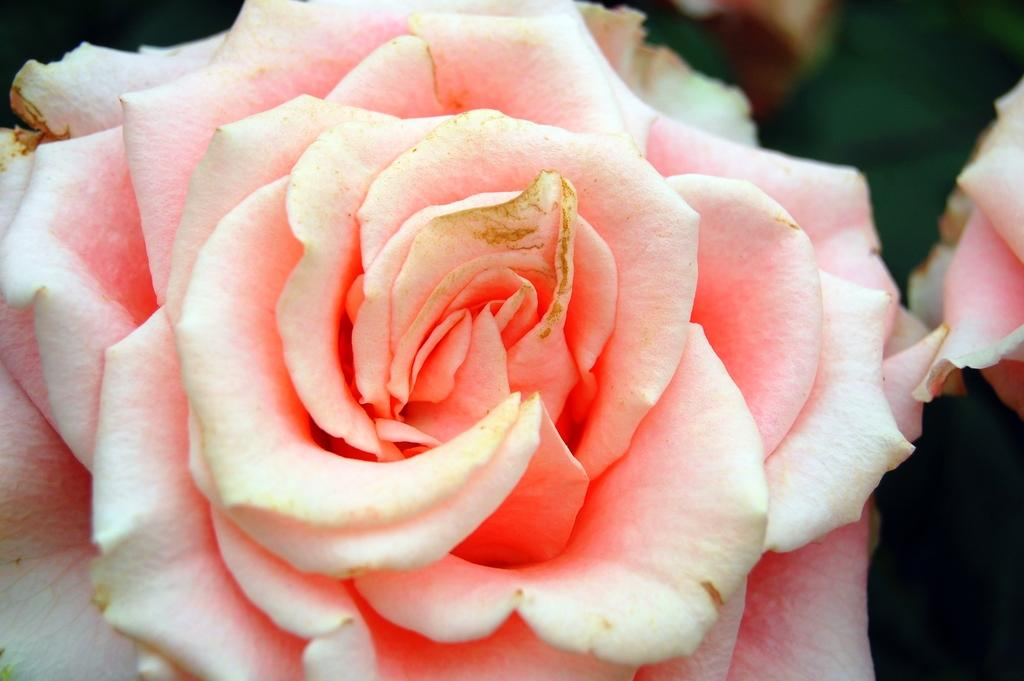What is the main subject of the image? There is a flower in the image. Can you describe the background of the image? The background of the image is blurred. What type of furniture is visible in the image? There is no furniture present in the image; it features a flower with a blurred background. Can you tell me how many rifles are depicted in the image? There are no rifles present in the image; it features a flower with a blurred background. 